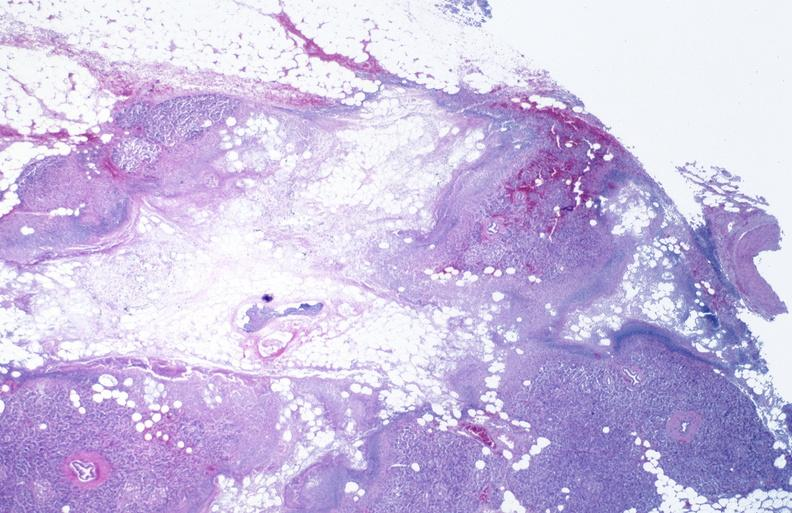where is this?
Answer the question using a single word or phrase. Pancreas 